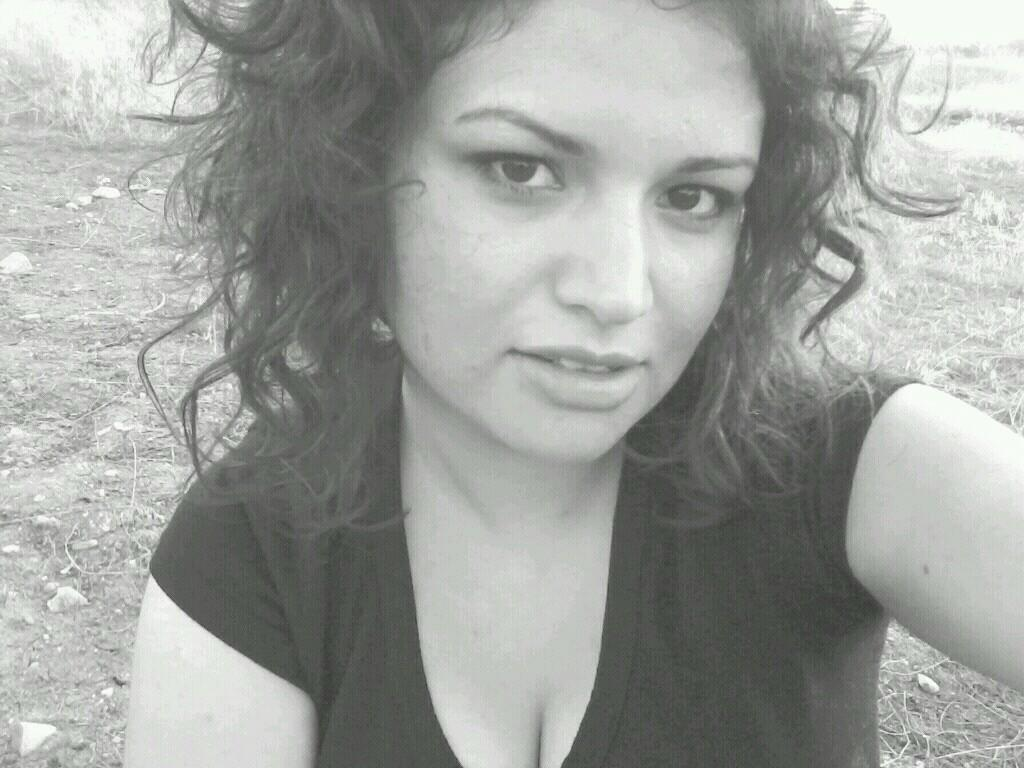What is the color scheme of the image? The image is black and white. Can you describe the main subject in the image? There is a woman in the image. What type of vegetable is the woman holding in the image? There is no vegetable present in the image; it only features a woman. 